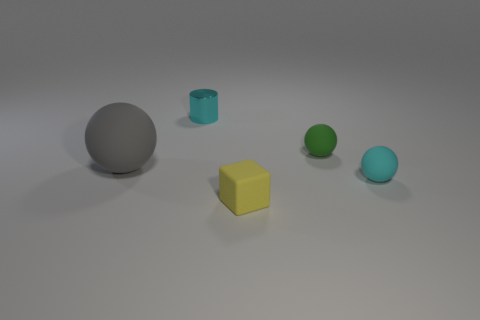Are there more small blue cubes than tiny metallic things?
Give a very brief answer. No. What is the size of the cyan matte thing that is the same shape as the small green thing?
Ensure brevity in your answer.  Small. Is the cylinder made of the same material as the big object in front of the green matte ball?
Your answer should be compact. No. How many things are small cyan shiny cylinders or tiny cyan metallic balls?
Keep it short and to the point. 1. There is a rubber sphere left of the small block; is it the same size as the cyan object behind the big gray object?
Make the answer very short. No. What number of balls are either yellow objects or tiny matte things?
Make the answer very short. 2. Is there a tiny blue metal object?
Your response must be concise. No. Is there anything else that has the same shape as the big matte object?
Offer a terse response. Yes. Do the big object and the cylinder have the same color?
Give a very brief answer. No. How many objects are either tiny spheres right of the small green object or large blue cubes?
Your answer should be compact. 1. 